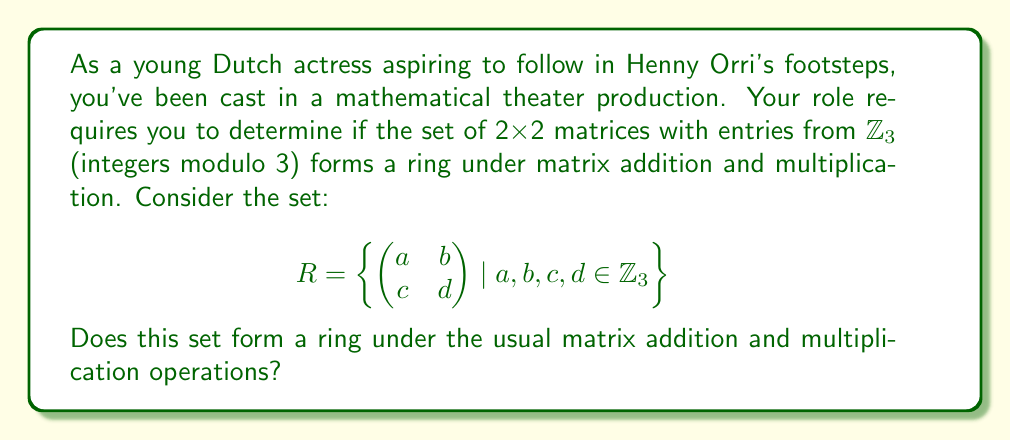Can you solve this math problem? To determine if the given set forms a ring, we need to check if it satisfies the ring axioms:

1. Closure under addition and multiplication:
   - Matrix addition: $(a_{ij}) + (b_{ij}) = (a_{ij} + b_{ij} \mod 3)$
   - Matrix multiplication: $(a_{ij})(b_{ij}) = (c_{ij})$, where $c_{ij} = \sum_{k=1}^2 a_{ik}b_{kj} \mod 3$
   Both operations result in matrices with entries in $\mathbb{Z}_3$, so closure is satisfied.

2. Associativity of addition and multiplication:
   - Matrix addition and multiplication are always associative.

3. Commutativity of addition:
   - Matrix addition is always commutative.

4. Additive identity:
   - The zero matrix $\begin{pmatrix} 0 & 0 \\ 0 & 0 \end{pmatrix}$ is in $R$ and serves as the additive identity.

5. Additive inverse:
   - For any matrix $A \in R$, its additive inverse is $-A \mod 3$, which is also in $R$.

6. Distributivity:
   - Matrix multiplication distributes over matrix addition.

7. Multiplicative identity:
   - The identity matrix $\begin{pmatrix} 1 & 0 \\ 0 & 1 \end{pmatrix}$ is in $R$ and serves as the multiplicative identity.

Since all ring axioms are satisfied, the set $R$ forms a ring under matrix addition and multiplication.
Answer: Yes, $R$ forms a ring. 